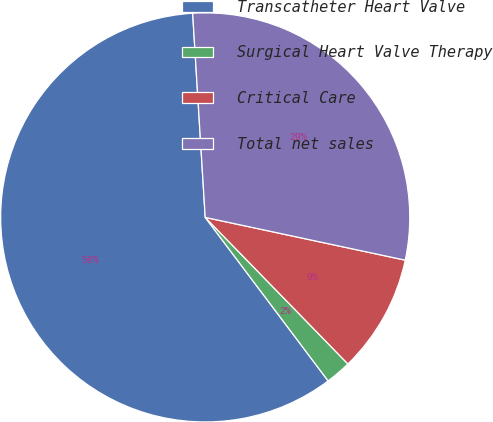Convert chart. <chart><loc_0><loc_0><loc_500><loc_500><pie_chart><fcel>Transcatheter Heart Valve<fcel>Surgical Heart Valve Therapy<fcel>Critical Care<fcel>Total net sales<nl><fcel>59.28%<fcel>2.03%<fcel>9.36%<fcel>29.33%<nl></chart> 